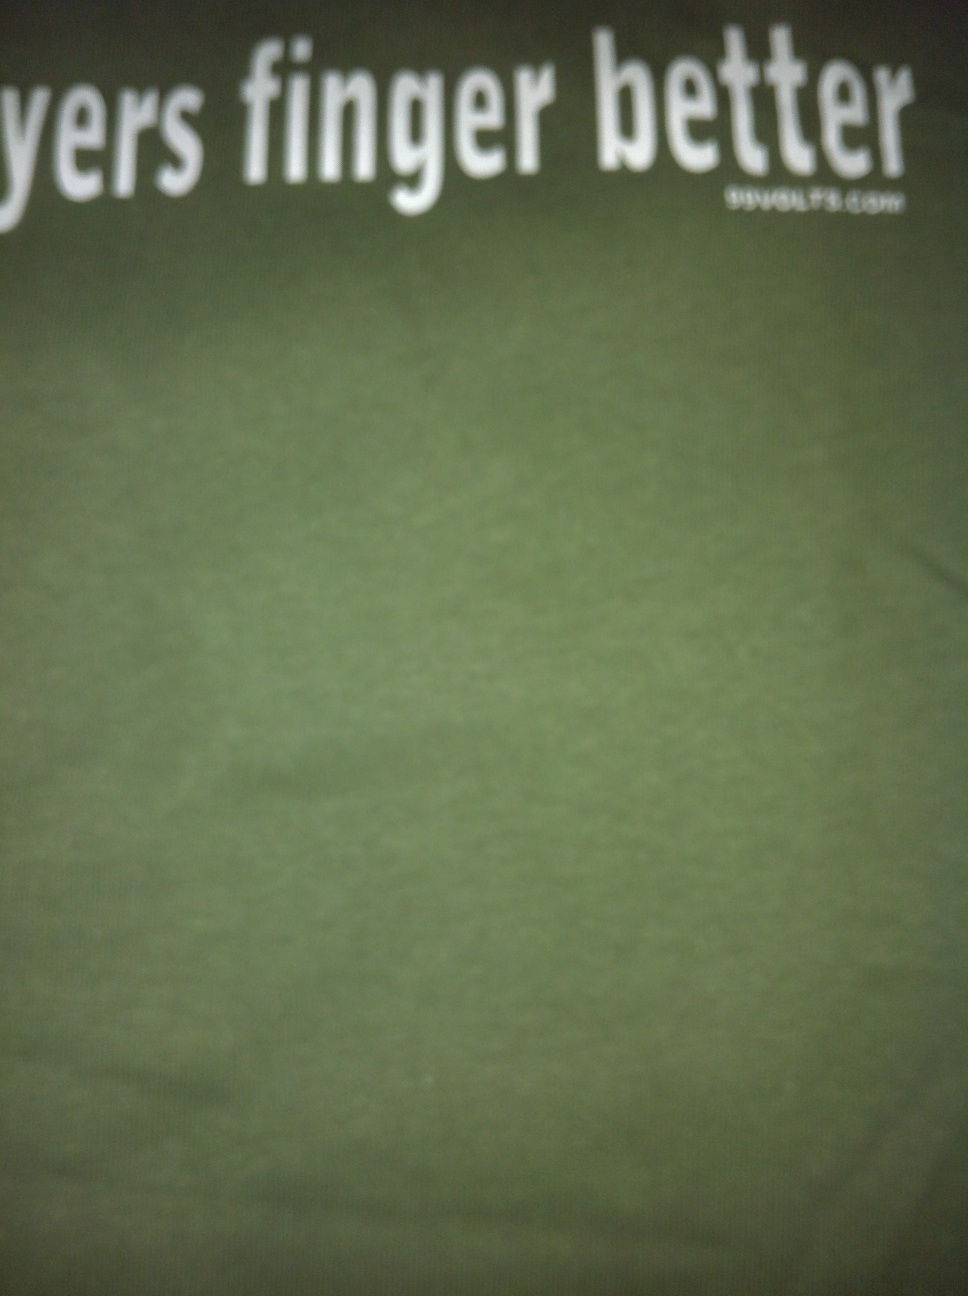What can you tell about the fabric quality of this t-shirt from its appearance in the image? From the image, the t-shirt appears to have a relatively uniform texture which is typical of cotton or a cotton blend. The fabric looks soft and comfortable, suitable for everyday wear. However, without touching it, it's difficult to determine the exact quality or thickness. 